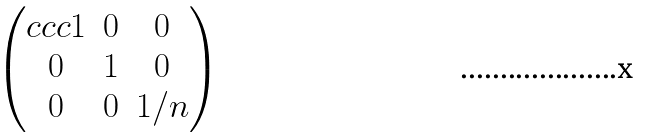Convert formula to latex. <formula><loc_0><loc_0><loc_500><loc_500>\begin{pmatrix} { c c c } 1 & 0 & 0 \\ 0 & 1 & 0 \\ 0 & 0 & 1 / n \end{pmatrix}</formula> 